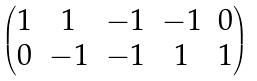Convert formula to latex. <formula><loc_0><loc_0><loc_500><loc_500>\begin{pmatrix} 1 & 1 & - 1 & - 1 & 0 \\ 0 & - 1 & - 1 & 1 & 1 \end{pmatrix}</formula> 